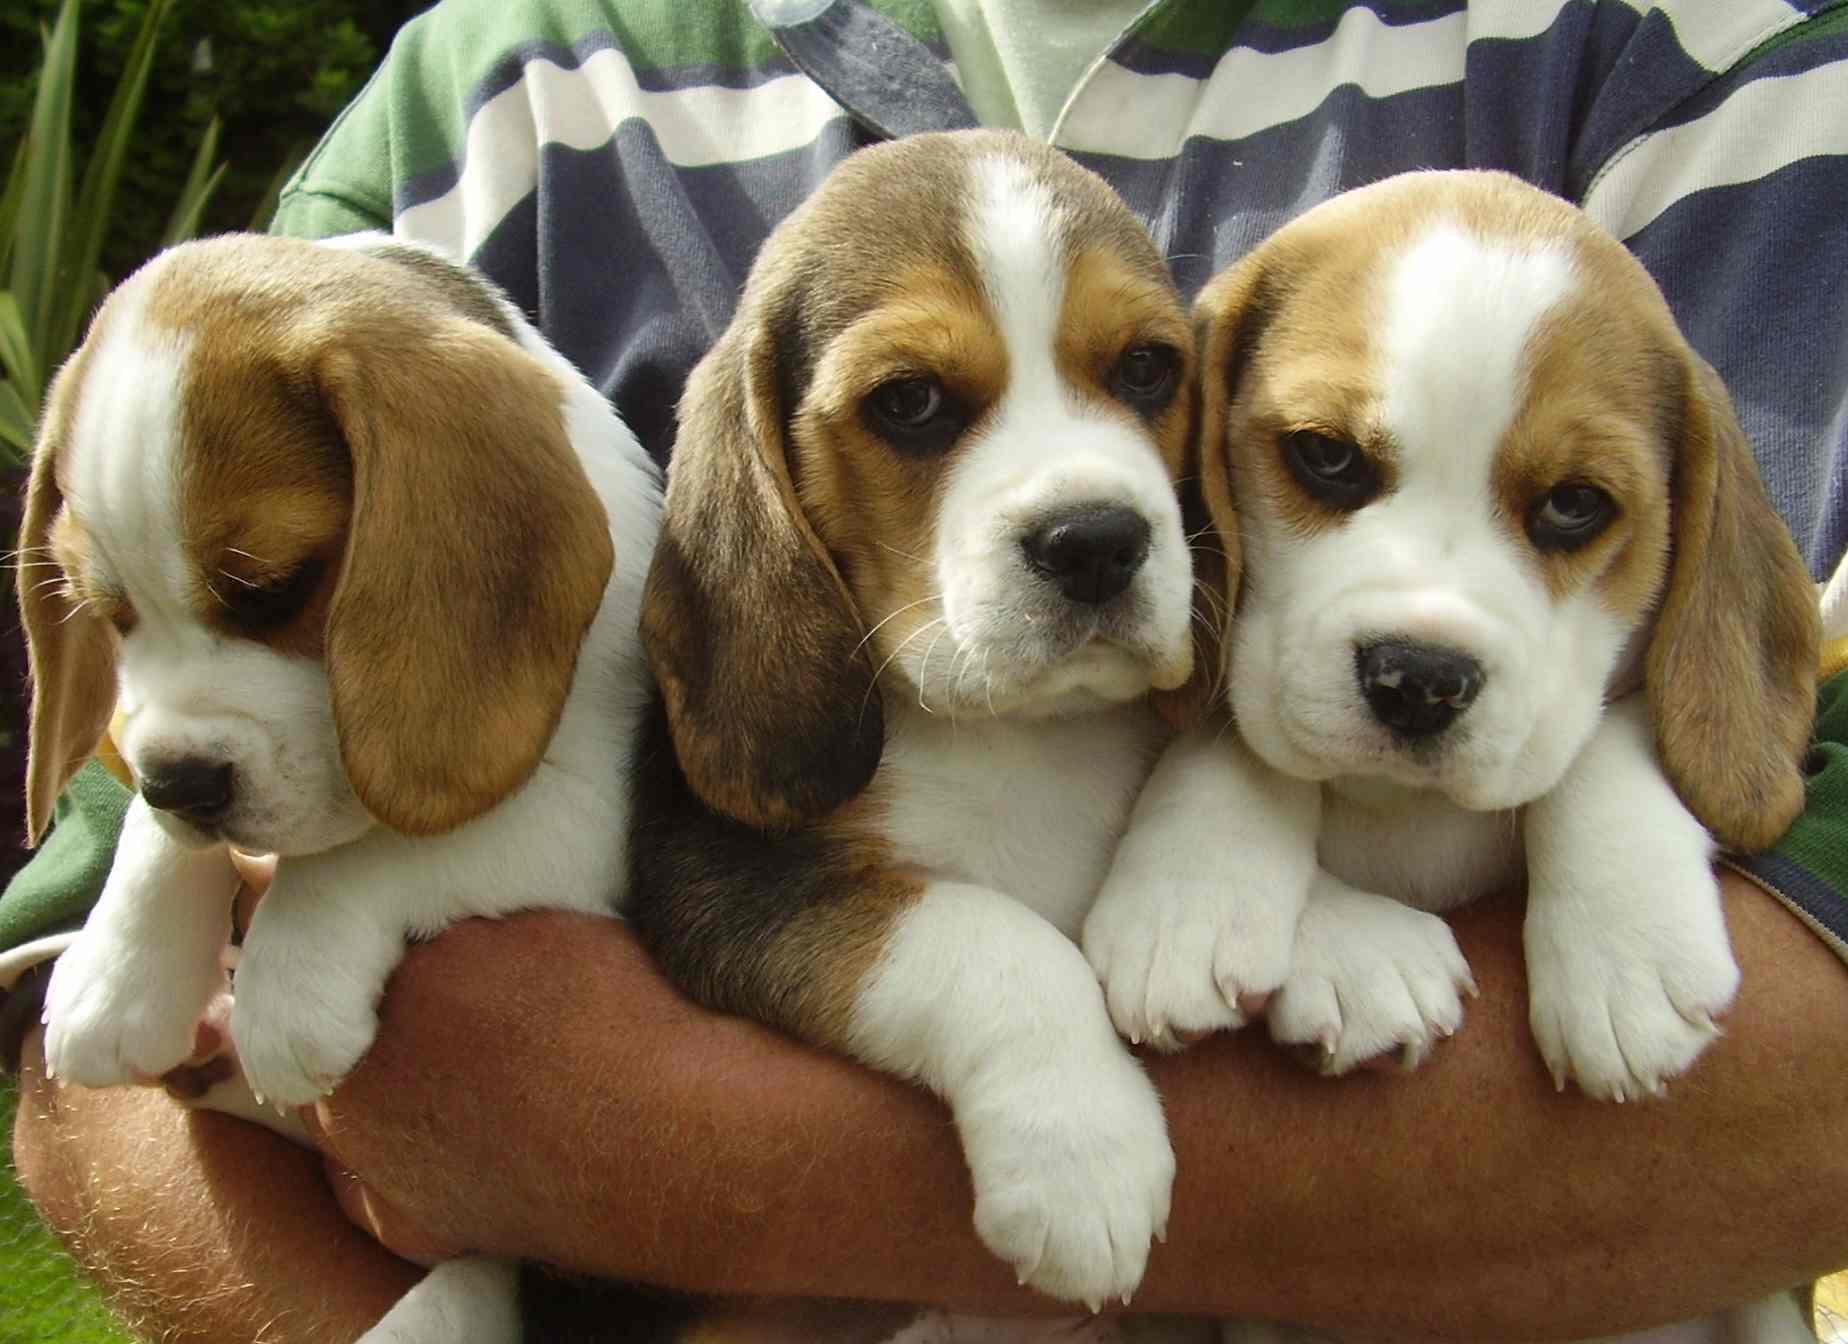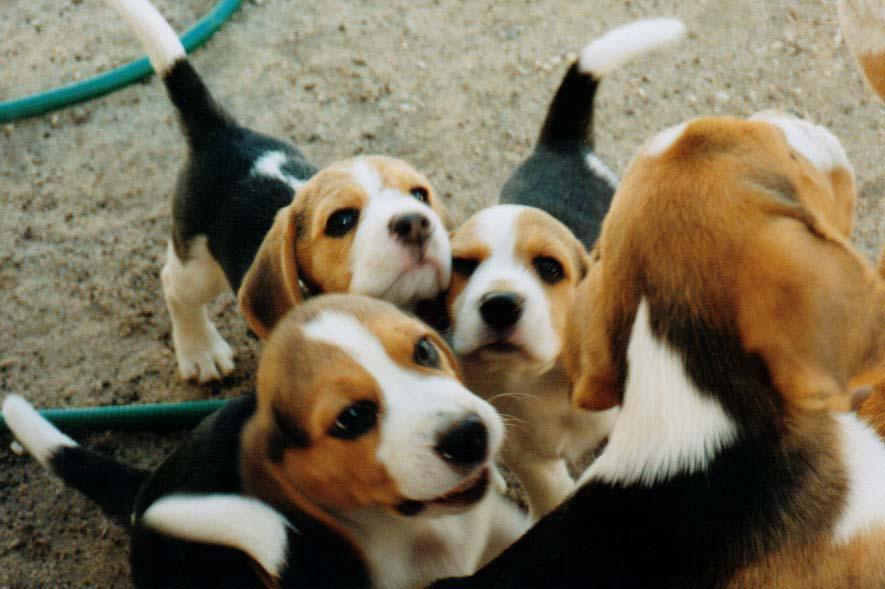The first image is the image on the left, the second image is the image on the right. Examine the images to the left and right. Is the description "There are more dogs in the right image than in the left image." accurate? Answer yes or no. Yes. The first image is the image on the left, the second image is the image on the right. For the images shown, is this caption "There are no more than 3 puppies in total." true? Answer yes or no. No. 